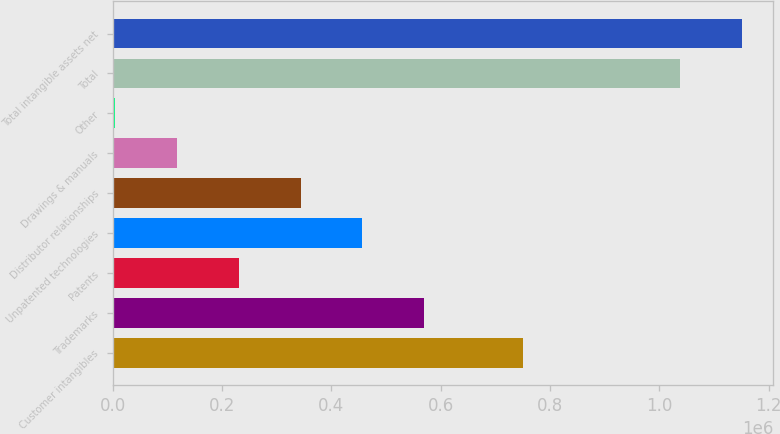Convert chart. <chart><loc_0><loc_0><loc_500><loc_500><bar_chart><fcel>Customer intangibles<fcel>Trademarks<fcel>Patents<fcel>Unpatented technologies<fcel>Distributor relationships<fcel>Drawings & manuals<fcel>Other<fcel>Total<fcel>Total intangible assets net<nl><fcel>750437<fcel>569734<fcel>231020<fcel>456829<fcel>343924<fcel>118116<fcel>5211<fcel>1.03759e+06<fcel>1.15049e+06<nl></chart> 